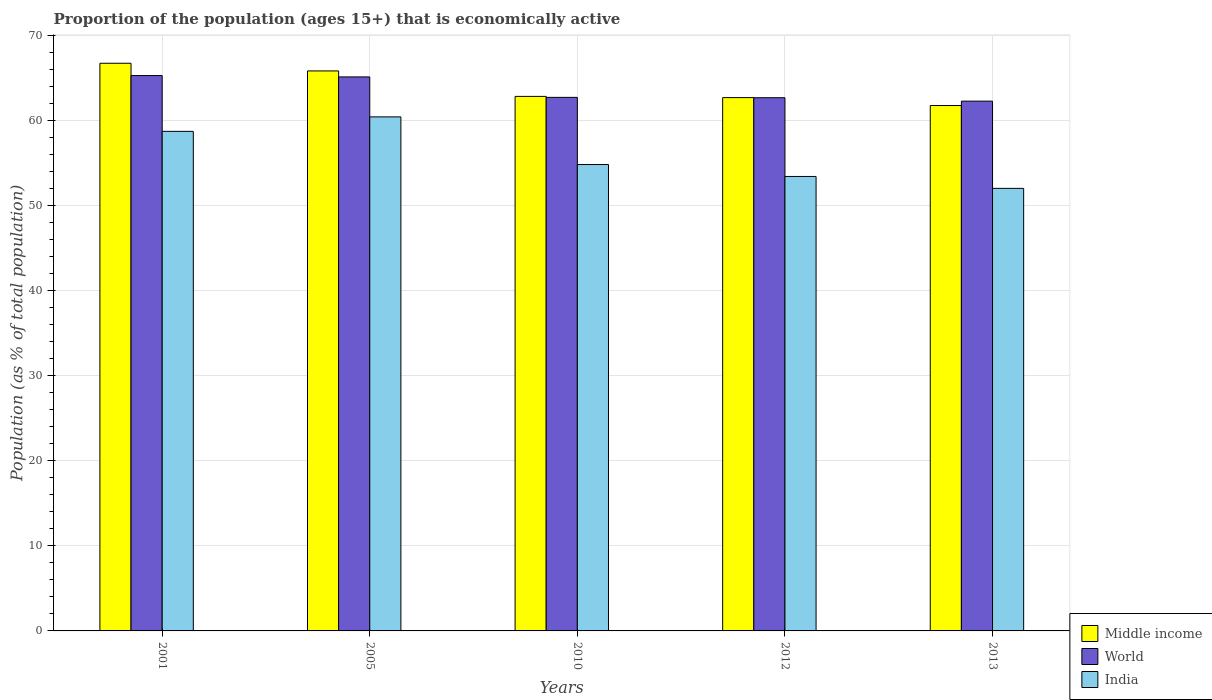How many different coloured bars are there?
Offer a terse response. 3. How many groups of bars are there?
Provide a short and direct response. 5. Are the number of bars per tick equal to the number of legend labels?
Provide a succinct answer. Yes. Are the number of bars on each tick of the X-axis equal?
Provide a short and direct response. Yes. In how many cases, is the number of bars for a given year not equal to the number of legend labels?
Keep it short and to the point. 0. What is the proportion of the population that is economically active in World in 2010?
Keep it short and to the point. 62.69. Across all years, what is the maximum proportion of the population that is economically active in Middle income?
Keep it short and to the point. 66.7. Across all years, what is the minimum proportion of the population that is economically active in Middle income?
Keep it short and to the point. 61.74. What is the total proportion of the population that is economically active in India in the graph?
Provide a short and direct response. 279.3. What is the difference between the proportion of the population that is economically active in India in 2001 and that in 2010?
Provide a short and direct response. 3.9. What is the difference between the proportion of the population that is economically active in India in 2012 and the proportion of the population that is economically active in World in 2013?
Ensure brevity in your answer.  -8.85. What is the average proportion of the population that is economically active in World per year?
Keep it short and to the point. 63.59. In the year 2001, what is the difference between the proportion of the population that is economically active in World and proportion of the population that is economically active in Middle income?
Keep it short and to the point. -1.45. What is the ratio of the proportion of the population that is economically active in India in 2010 to that in 2012?
Your answer should be very brief. 1.03. Is the difference between the proportion of the population that is economically active in World in 2001 and 2012 greater than the difference between the proportion of the population that is economically active in Middle income in 2001 and 2012?
Your answer should be compact. No. What is the difference between the highest and the second highest proportion of the population that is economically active in India?
Offer a terse response. 1.7. What is the difference between the highest and the lowest proportion of the population that is economically active in India?
Keep it short and to the point. 8.4. In how many years, is the proportion of the population that is economically active in World greater than the average proportion of the population that is economically active in World taken over all years?
Provide a short and direct response. 2. Is the sum of the proportion of the population that is economically active in Middle income in 2001 and 2010 greater than the maximum proportion of the population that is economically active in World across all years?
Your answer should be very brief. Yes. Does the graph contain any zero values?
Your answer should be compact. No. How many legend labels are there?
Your answer should be very brief. 3. What is the title of the graph?
Provide a succinct answer. Proportion of the population (ages 15+) that is economically active. What is the label or title of the X-axis?
Provide a succinct answer. Years. What is the label or title of the Y-axis?
Give a very brief answer. Population (as % of total population). What is the Population (as % of total population) in Middle income in 2001?
Make the answer very short. 66.7. What is the Population (as % of total population) of World in 2001?
Keep it short and to the point. 65.26. What is the Population (as % of total population) of India in 2001?
Keep it short and to the point. 58.7. What is the Population (as % of total population) of Middle income in 2005?
Provide a succinct answer. 65.8. What is the Population (as % of total population) of World in 2005?
Make the answer very short. 65.1. What is the Population (as % of total population) in India in 2005?
Your answer should be compact. 60.4. What is the Population (as % of total population) of Middle income in 2010?
Offer a very short reply. 62.81. What is the Population (as % of total population) of World in 2010?
Make the answer very short. 62.69. What is the Population (as % of total population) in India in 2010?
Your answer should be compact. 54.8. What is the Population (as % of total population) of Middle income in 2012?
Make the answer very short. 62.66. What is the Population (as % of total population) in World in 2012?
Offer a terse response. 62.65. What is the Population (as % of total population) in India in 2012?
Provide a succinct answer. 53.4. What is the Population (as % of total population) of Middle income in 2013?
Give a very brief answer. 61.74. What is the Population (as % of total population) of World in 2013?
Provide a short and direct response. 62.25. What is the Population (as % of total population) in India in 2013?
Your answer should be compact. 52. Across all years, what is the maximum Population (as % of total population) in Middle income?
Your answer should be compact. 66.7. Across all years, what is the maximum Population (as % of total population) in World?
Offer a terse response. 65.26. Across all years, what is the maximum Population (as % of total population) in India?
Provide a short and direct response. 60.4. Across all years, what is the minimum Population (as % of total population) of Middle income?
Your answer should be compact. 61.74. Across all years, what is the minimum Population (as % of total population) of World?
Keep it short and to the point. 62.25. Across all years, what is the minimum Population (as % of total population) of India?
Keep it short and to the point. 52. What is the total Population (as % of total population) in Middle income in the graph?
Give a very brief answer. 319.71. What is the total Population (as % of total population) in World in the graph?
Give a very brief answer. 317.95. What is the total Population (as % of total population) of India in the graph?
Make the answer very short. 279.3. What is the difference between the Population (as % of total population) in Middle income in 2001 and that in 2005?
Keep it short and to the point. 0.9. What is the difference between the Population (as % of total population) of World in 2001 and that in 2005?
Your answer should be very brief. 0.16. What is the difference between the Population (as % of total population) of India in 2001 and that in 2005?
Make the answer very short. -1.7. What is the difference between the Population (as % of total population) of Middle income in 2001 and that in 2010?
Provide a succinct answer. 3.89. What is the difference between the Population (as % of total population) in World in 2001 and that in 2010?
Your answer should be very brief. 2.56. What is the difference between the Population (as % of total population) in India in 2001 and that in 2010?
Give a very brief answer. 3.9. What is the difference between the Population (as % of total population) in Middle income in 2001 and that in 2012?
Your response must be concise. 4.04. What is the difference between the Population (as % of total population) in World in 2001 and that in 2012?
Offer a very short reply. 2.6. What is the difference between the Population (as % of total population) of Middle income in 2001 and that in 2013?
Your answer should be compact. 4.97. What is the difference between the Population (as % of total population) in World in 2001 and that in 2013?
Your response must be concise. 3. What is the difference between the Population (as % of total population) of Middle income in 2005 and that in 2010?
Your answer should be compact. 2.99. What is the difference between the Population (as % of total population) of World in 2005 and that in 2010?
Provide a succinct answer. 2.4. What is the difference between the Population (as % of total population) in Middle income in 2005 and that in 2012?
Give a very brief answer. 3.13. What is the difference between the Population (as % of total population) of World in 2005 and that in 2012?
Provide a succinct answer. 2.44. What is the difference between the Population (as % of total population) in India in 2005 and that in 2012?
Offer a very short reply. 7. What is the difference between the Population (as % of total population) of Middle income in 2005 and that in 2013?
Your response must be concise. 4.06. What is the difference between the Population (as % of total population) of World in 2005 and that in 2013?
Offer a terse response. 2.84. What is the difference between the Population (as % of total population) in India in 2005 and that in 2013?
Provide a short and direct response. 8.4. What is the difference between the Population (as % of total population) in Middle income in 2010 and that in 2012?
Offer a very short reply. 0.14. What is the difference between the Population (as % of total population) in World in 2010 and that in 2012?
Provide a short and direct response. 0.04. What is the difference between the Population (as % of total population) of India in 2010 and that in 2012?
Offer a very short reply. 1.4. What is the difference between the Population (as % of total population) in Middle income in 2010 and that in 2013?
Give a very brief answer. 1.07. What is the difference between the Population (as % of total population) in World in 2010 and that in 2013?
Offer a terse response. 0.44. What is the difference between the Population (as % of total population) of Middle income in 2012 and that in 2013?
Offer a terse response. 0.93. What is the difference between the Population (as % of total population) in World in 2012 and that in 2013?
Give a very brief answer. 0.4. What is the difference between the Population (as % of total population) of India in 2012 and that in 2013?
Make the answer very short. 1.4. What is the difference between the Population (as % of total population) in Middle income in 2001 and the Population (as % of total population) in World in 2005?
Make the answer very short. 1.61. What is the difference between the Population (as % of total population) of Middle income in 2001 and the Population (as % of total population) of India in 2005?
Your answer should be very brief. 6.3. What is the difference between the Population (as % of total population) of World in 2001 and the Population (as % of total population) of India in 2005?
Offer a very short reply. 4.86. What is the difference between the Population (as % of total population) in Middle income in 2001 and the Population (as % of total population) in World in 2010?
Offer a terse response. 4.01. What is the difference between the Population (as % of total population) in Middle income in 2001 and the Population (as % of total population) in India in 2010?
Offer a very short reply. 11.9. What is the difference between the Population (as % of total population) in World in 2001 and the Population (as % of total population) in India in 2010?
Offer a terse response. 10.46. What is the difference between the Population (as % of total population) in Middle income in 2001 and the Population (as % of total population) in World in 2012?
Your answer should be very brief. 4.05. What is the difference between the Population (as % of total population) of Middle income in 2001 and the Population (as % of total population) of India in 2012?
Your answer should be very brief. 13.3. What is the difference between the Population (as % of total population) in World in 2001 and the Population (as % of total population) in India in 2012?
Your answer should be very brief. 11.86. What is the difference between the Population (as % of total population) in Middle income in 2001 and the Population (as % of total population) in World in 2013?
Your answer should be very brief. 4.45. What is the difference between the Population (as % of total population) in Middle income in 2001 and the Population (as % of total population) in India in 2013?
Offer a terse response. 14.7. What is the difference between the Population (as % of total population) in World in 2001 and the Population (as % of total population) in India in 2013?
Your answer should be very brief. 13.26. What is the difference between the Population (as % of total population) of Middle income in 2005 and the Population (as % of total population) of World in 2010?
Give a very brief answer. 3.11. What is the difference between the Population (as % of total population) in Middle income in 2005 and the Population (as % of total population) in India in 2010?
Your response must be concise. 11. What is the difference between the Population (as % of total population) of World in 2005 and the Population (as % of total population) of India in 2010?
Keep it short and to the point. 10.3. What is the difference between the Population (as % of total population) in Middle income in 2005 and the Population (as % of total population) in World in 2012?
Keep it short and to the point. 3.15. What is the difference between the Population (as % of total population) in Middle income in 2005 and the Population (as % of total population) in India in 2012?
Make the answer very short. 12.4. What is the difference between the Population (as % of total population) of World in 2005 and the Population (as % of total population) of India in 2012?
Your response must be concise. 11.7. What is the difference between the Population (as % of total population) in Middle income in 2005 and the Population (as % of total population) in World in 2013?
Provide a short and direct response. 3.55. What is the difference between the Population (as % of total population) in Middle income in 2005 and the Population (as % of total population) in India in 2013?
Ensure brevity in your answer.  13.8. What is the difference between the Population (as % of total population) in World in 2005 and the Population (as % of total population) in India in 2013?
Provide a short and direct response. 13.1. What is the difference between the Population (as % of total population) in Middle income in 2010 and the Population (as % of total population) in World in 2012?
Provide a succinct answer. 0.16. What is the difference between the Population (as % of total population) in Middle income in 2010 and the Population (as % of total population) in India in 2012?
Give a very brief answer. 9.41. What is the difference between the Population (as % of total population) of World in 2010 and the Population (as % of total population) of India in 2012?
Your response must be concise. 9.29. What is the difference between the Population (as % of total population) in Middle income in 2010 and the Population (as % of total population) in World in 2013?
Provide a short and direct response. 0.56. What is the difference between the Population (as % of total population) in Middle income in 2010 and the Population (as % of total population) in India in 2013?
Offer a terse response. 10.81. What is the difference between the Population (as % of total population) of World in 2010 and the Population (as % of total population) of India in 2013?
Give a very brief answer. 10.69. What is the difference between the Population (as % of total population) of Middle income in 2012 and the Population (as % of total population) of World in 2013?
Your answer should be compact. 0.41. What is the difference between the Population (as % of total population) in Middle income in 2012 and the Population (as % of total population) in India in 2013?
Give a very brief answer. 10.66. What is the difference between the Population (as % of total population) in World in 2012 and the Population (as % of total population) in India in 2013?
Your answer should be very brief. 10.65. What is the average Population (as % of total population) of Middle income per year?
Your answer should be compact. 63.94. What is the average Population (as % of total population) of World per year?
Your response must be concise. 63.59. What is the average Population (as % of total population) in India per year?
Your response must be concise. 55.86. In the year 2001, what is the difference between the Population (as % of total population) of Middle income and Population (as % of total population) of World?
Your answer should be very brief. 1.45. In the year 2001, what is the difference between the Population (as % of total population) of Middle income and Population (as % of total population) of India?
Your answer should be very brief. 8. In the year 2001, what is the difference between the Population (as % of total population) in World and Population (as % of total population) in India?
Offer a terse response. 6.56. In the year 2005, what is the difference between the Population (as % of total population) in Middle income and Population (as % of total population) in World?
Make the answer very short. 0.7. In the year 2005, what is the difference between the Population (as % of total population) of Middle income and Population (as % of total population) of India?
Offer a terse response. 5.4. In the year 2005, what is the difference between the Population (as % of total population) of World and Population (as % of total population) of India?
Make the answer very short. 4.7. In the year 2010, what is the difference between the Population (as % of total population) in Middle income and Population (as % of total population) in World?
Your response must be concise. 0.11. In the year 2010, what is the difference between the Population (as % of total population) of Middle income and Population (as % of total population) of India?
Provide a short and direct response. 8.01. In the year 2010, what is the difference between the Population (as % of total population) of World and Population (as % of total population) of India?
Offer a very short reply. 7.89. In the year 2012, what is the difference between the Population (as % of total population) of Middle income and Population (as % of total population) of World?
Ensure brevity in your answer.  0.01. In the year 2012, what is the difference between the Population (as % of total population) in Middle income and Population (as % of total population) in India?
Give a very brief answer. 9.26. In the year 2012, what is the difference between the Population (as % of total population) of World and Population (as % of total population) of India?
Your answer should be very brief. 9.25. In the year 2013, what is the difference between the Population (as % of total population) in Middle income and Population (as % of total population) in World?
Your answer should be very brief. -0.52. In the year 2013, what is the difference between the Population (as % of total population) of Middle income and Population (as % of total population) of India?
Provide a short and direct response. 9.74. In the year 2013, what is the difference between the Population (as % of total population) in World and Population (as % of total population) in India?
Offer a terse response. 10.25. What is the ratio of the Population (as % of total population) of Middle income in 2001 to that in 2005?
Keep it short and to the point. 1.01. What is the ratio of the Population (as % of total population) in World in 2001 to that in 2005?
Offer a very short reply. 1. What is the ratio of the Population (as % of total population) of India in 2001 to that in 2005?
Provide a short and direct response. 0.97. What is the ratio of the Population (as % of total population) in Middle income in 2001 to that in 2010?
Ensure brevity in your answer.  1.06. What is the ratio of the Population (as % of total population) of World in 2001 to that in 2010?
Offer a terse response. 1.04. What is the ratio of the Population (as % of total population) of India in 2001 to that in 2010?
Offer a terse response. 1.07. What is the ratio of the Population (as % of total population) of Middle income in 2001 to that in 2012?
Keep it short and to the point. 1.06. What is the ratio of the Population (as % of total population) in World in 2001 to that in 2012?
Make the answer very short. 1.04. What is the ratio of the Population (as % of total population) in India in 2001 to that in 2012?
Offer a very short reply. 1.1. What is the ratio of the Population (as % of total population) of Middle income in 2001 to that in 2013?
Provide a succinct answer. 1.08. What is the ratio of the Population (as % of total population) in World in 2001 to that in 2013?
Provide a succinct answer. 1.05. What is the ratio of the Population (as % of total population) in India in 2001 to that in 2013?
Keep it short and to the point. 1.13. What is the ratio of the Population (as % of total population) of Middle income in 2005 to that in 2010?
Offer a very short reply. 1.05. What is the ratio of the Population (as % of total population) of World in 2005 to that in 2010?
Offer a terse response. 1.04. What is the ratio of the Population (as % of total population) of India in 2005 to that in 2010?
Give a very brief answer. 1.1. What is the ratio of the Population (as % of total population) of World in 2005 to that in 2012?
Your response must be concise. 1.04. What is the ratio of the Population (as % of total population) in India in 2005 to that in 2012?
Provide a short and direct response. 1.13. What is the ratio of the Population (as % of total population) in Middle income in 2005 to that in 2013?
Give a very brief answer. 1.07. What is the ratio of the Population (as % of total population) of World in 2005 to that in 2013?
Keep it short and to the point. 1.05. What is the ratio of the Population (as % of total population) of India in 2005 to that in 2013?
Your response must be concise. 1.16. What is the ratio of the Population (as % of total population) in India in 2010 to that in 2012?
Make the answer very short. 1.03. What is the ratio of the Population (as % of total population) in Middle income in 2010 to that in 2013?
Ensure brevity in your answer.  1.02. What is the ratio of the Population (as % of total population) of World in 2010 to that in 2013?
Keep it short and to the point. 1.01. What is the ratio of the Population (as % of total population) of India in 2010 to that in 2013?
Keep it short and to the point. 1.05. What is the ratio of the Population (as % of total population) of Middle income in 2012 to that in 2013?
Your answer should be very brief. 1.02. What is the ratio of the Population (as % of total population) of World in 2012 to that in 2013?
Ensure brevity in your answer.  1.01. What is the ratio of the Population (as % of total population) of India in 2012 to that in 2013?
Your answer should be very brief. 1.03. What is the difference between the highest and the second highest Population (as % of total population) of Middle income?
Give a very brief answer. 0.9. What is the difference between the highest and the second highest Population (as % of total population) in World?
Give a very brief answer. 0.16. What is the difference between the highest and the second highest Population (as % of total population) in India?
Give a very brief answer. 1.7. What is the difference between the highest and the lowest Population (as % of total population) in Middle income?
Your answer should be very brief. 4.97. What is the difference between the highest and the lowest Population (as % of total population) in World?
Provide a short and direct response. 3. 